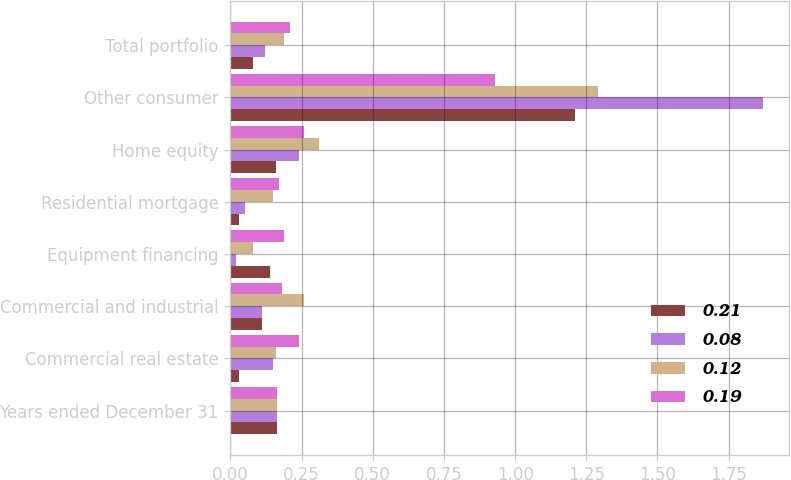Convert chart. <chart><loc_0><loc_0><loc_500><loc_500><stacked_bar_chart><ecel><fcel>Years ended December 31<fcel>Commercial real estate<fcel>Commercial and industrial<fcel>Equipment financing<fcel>Residential mortgage<fcel>Home equity<fcel>Other consumer<fcel>Total portfolio<nl><fcel>0.21<fcel>0.165<fcel>0.03<fcel>0.11<fcel>0.14<fcel>0.03<fcel>0.16<fcel>1.21<fcel>0.08<nl><fcel>0.08<fcel>0.165<fcel>0.15<fcel>0.11<fcel>0.02<fcel>0.05<fcel>0.24<fcel>1.87<fcel>0.12<nl><fcel>0.12<fcel>0.165<fcel>0.16<fcel>0.26<fcel>0.08<fcel>0.15<fcel>0.31<fcel>1.29<fcel>0.19<nl><fcel>0.19<fcel>0.165<fcel>0.24<fcel>0.18<fcel>0.19<fcel>0.17<fcel>0.26<fcel>0.93<fcel>0.21<nl></chart> 